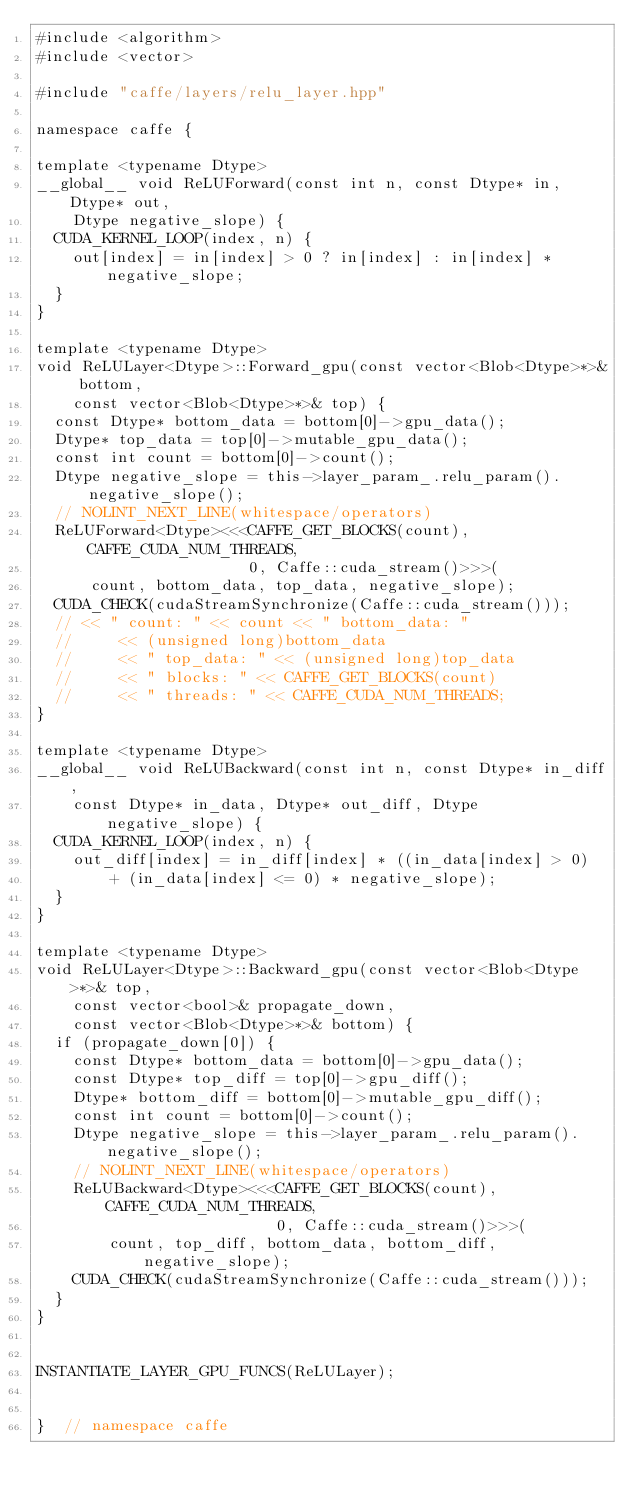<code> <loc_0><loc_0><loc_500><loc_500><_Cuda_>#include <algorithm>
#include <vector>

#include "caffe/layers/relu_layer.hpp"

namespace caffe {

template <typename Dtype>
__global__ void ReLUForward(const int n, const Dtype* in, Dtype* out,
    Dtype negative_slope) {
  CUDA_KERNEL_LOOP(index, n) {
    out[index] = in[index] > 0 ? in[index] : in[index] * negative_slope;
  }
}

template <typename Dtype>
void ReLULayer<Dtype>::Forward_gpu(const vector<Blob<Dtype>*>& bottom,
    const vector<Blob<Dtype>*>& top) {
  const Dtype* bottom_data = bottom[0]->gpu_data();
  Dtype* top_data = top[0]->mutable_gpu_data();
  const int count = bottom[0]->count();
  Dtype negative_slope = this->layer_param_.relu_param().negative_slope();
  // NOLINT_NEXT_LINE(whitespace/operators)
  ReLUForward<Dtype><<<CAFFE_GET_BLOCKS(count), CAFFE_CUDA_NUM_THREADS,
                       0, Caffe::cuda_stream()>>>(
      count, bottom_data, top_data, negative_slope);
  CUDA_CHECK(cudaStreamSynchronize(Caffe::cuda_stream()));
  // << " count: " << count << " bottom_data: "
  //     << (unsigned long)bottom_data
  //     << " top_data: " << (unsigned long)top_data
  //     << " blocks: " << CAFFE_GET_BLOCKS(count)
  //     << " threads: " << CAFFE_CUDA_NUM_THREADS;
}

template <typename Dtype>
__global__ void ReLUBackward(const int n, const Dtype* in_diff,
    const Dtype* in_data, Dtype* out_diff, Dtype negative_slope) {
  CUDA_KERNEL_LOOP(index, n) {
    out_diff[index] = in_diff[index] * ((in_data[index] > 0)
        + (in_data[index] <= 0) * negative_slope);
  }
}

template <typename Dtype>
void ReLULayer<Dtype>::Backward_gpu(const vector<Blob<Dtype>*>& top,
    const vector<bool>& propagate_down,
    const vector<Blob<Dtype>*>& bottom) {
  if (propagate_down[0]) {
    const Dtype* bottom_data = bottom[0]->gpu_data();
    const Dtype* top_diff = top[0]->gpu_diff();
    Dtype* bottom_diff = bottom[0]->mutable_gpu_diff();
    const int count = bottom[0]->count();
    Dtype negative_slope = this->layer_param_.relu_param().negative_slope();
    // NOLINT_NEXT_LINE(whitespace/operators)
    ReLUBackward<Dtype><<<CAFFE_GET_BLOCKS(count), CAFFE_CUDA_NUM_THREADS,
                          0, Caffe::cuda_stream()>>>(
        count, top_diff, bottom_data, bottom_diff, negative_slope);
    CUDA_CHECK(cudaStreamSynchronize(Caffe::cuda_stream()));
  }
}


INSTANTIATE_LAYER_GPU_FUNCS(ReLULayer);


}  // namespace caffe
</code> 